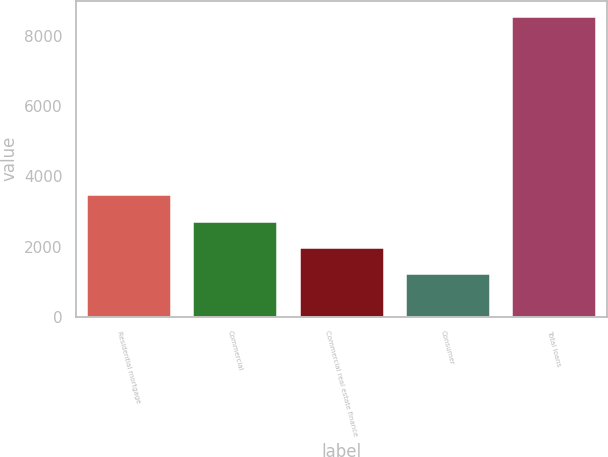Convert chart to OTSL. <chart><loc_0><loc_0><loc_500><loc_500><bar_chart><fcel>Residential mortgage<fcel>Commercial<fcel>Commercial real estate finance<fcel>Consumer<fcel>Total loans<nl><fcel>3507.9<fcel>2720.58<fcel>1989.04<fcel>1257.5<fcel>8572.9<nl></chart> 